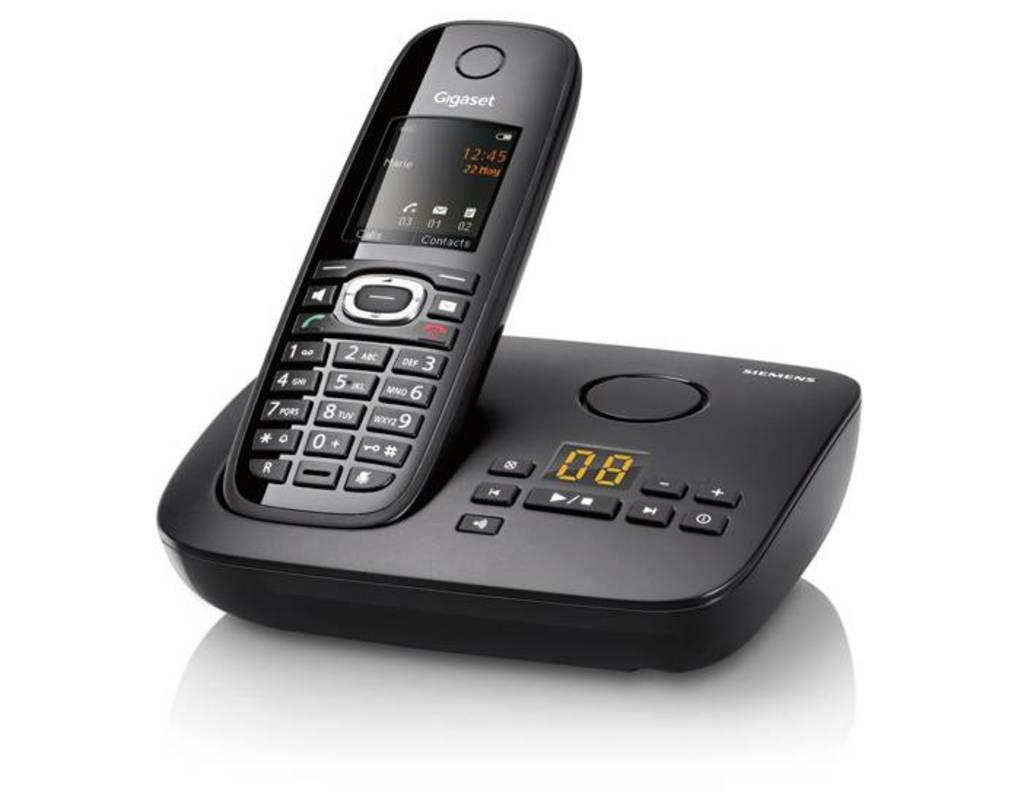<image>
Give a short and clear explanation of the subsequent image. a black siemens cordless telephone in its charging base 